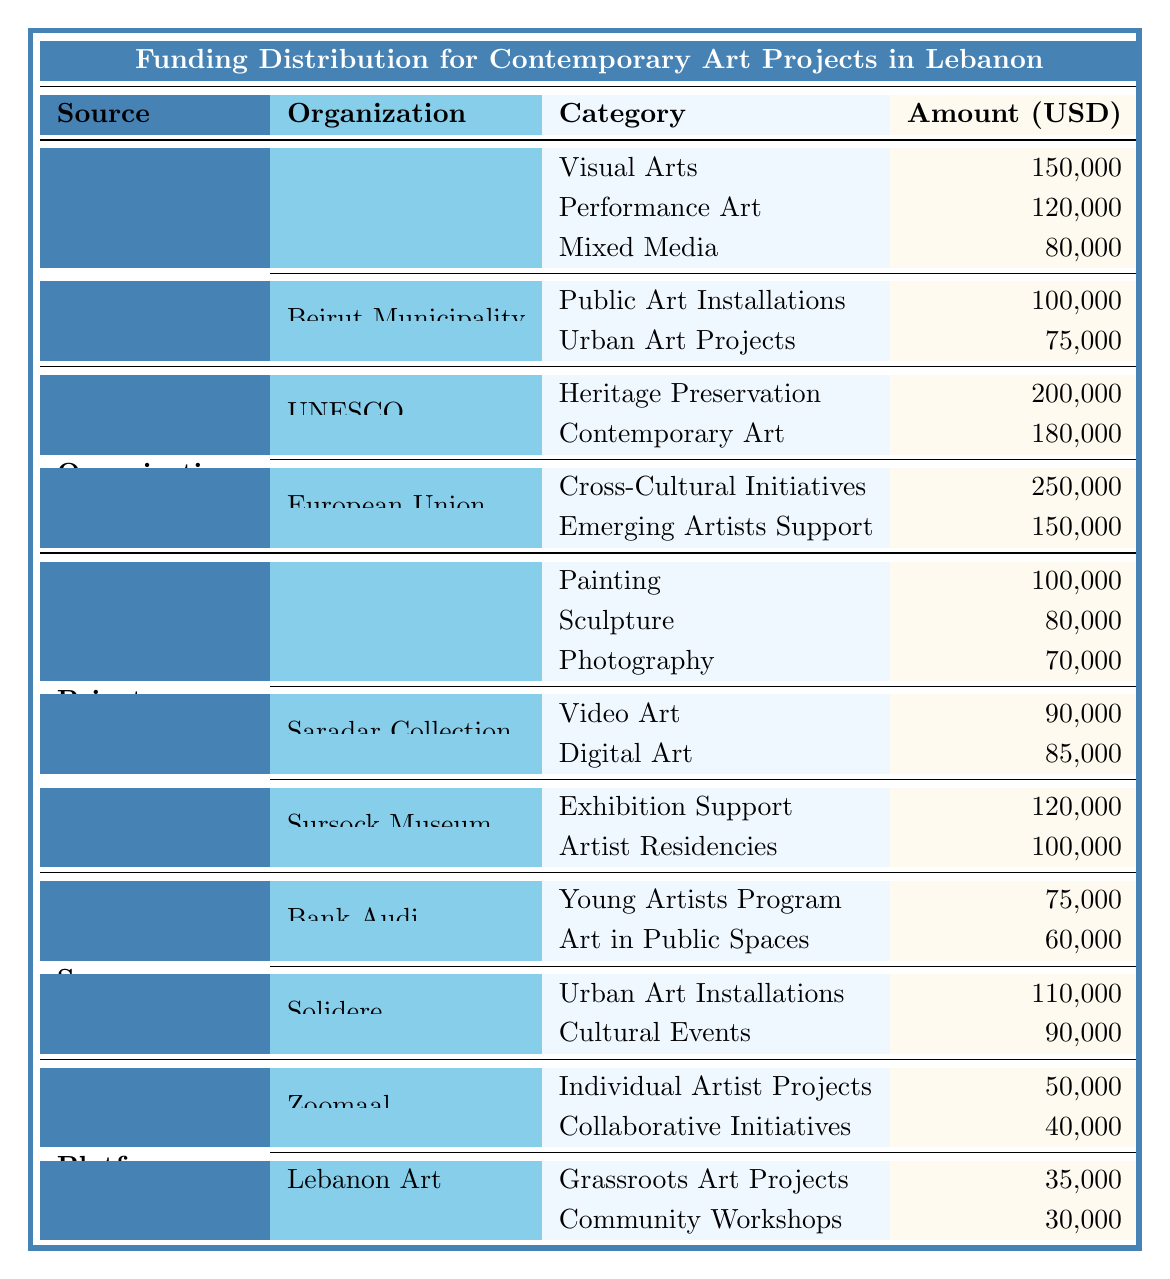What is the total amount of funding from the Ministry of Culture? By reviewing the entries under the Ministry of Culture, the funded categories are Visual Arts (150,000), Performance Art (120,000), and Mixed Media (80,000). Adding these amounts: 150,000 + 120,000 + 80,000 = 350,000.
Answer: 350,000 Which organization received the highest funding for arts projects? The highest single entry in the table is from the European Union under Cross-Cultural Initiatives, which received 250,000.
Answer: 250,000 Did Bank Audi fund any projects above 70,000? Yes, the Young Artists Program received 75,000 and Art in Public Spaces received 60,000, so one project (Young Artists Program) was above 70,000.
Answer: Yes How much funding was allocated to Private Foundations in total? The funding amounts for Private Foundations are as follows: Aishti Foundation (100,000 + 80,000 + 70,000 = 250,000), Saradar Collection (90,000 + 85,000 = 175,000), and Sursock Museum (120,000 + 100,000 = 220,000). Summing these totals: 250,000 + 175,000 + 220,000 = 645,000.
Answer: 645,000 What percentage of the total funding from the International Organizations came from UNESCO? The total funding from International Organizations is their respective amounts: UNESCO (200,000 + 180,000 = 380,000) and European Union (250,000 + 150,000 = 400,000), total is 380,000 + 400,000 = 780,000. The portion from UNESCO is 380,000. Calculating the percentage: (380,000 / 780,000) * 100 = 48.72%.
Answer: 48.72% Which category received the least amount of funding overall? Looking through all categories, the least amount recorded is with Community Workshops (30,000) under the Crowdfunding Platforms.
Answer: Community Workshops How much funding did the Beirut Municipality provide for Urban Art Projects compared to Public Art Installations? Beirut Municipality provided 75,000 for Urban Art Projects and 100,000 for Public Art Installations. Public Art Installations received more funding than Urban Art Projects.
Answer: 100,000 vs 75,000 Is the total funding for all Crowdfunding Platforms greater than that of Corporate Sponsors? The total for Crowdfunding Platforms is (50,000 + 40,000 + 35,000 + 30,000 = 155,000) while Corporate Sponsors received (75,000 + 60,000 + 110,000 + 90,000 = 335,000). So, 155,000 is not greater than 335,000.
Answer: No 